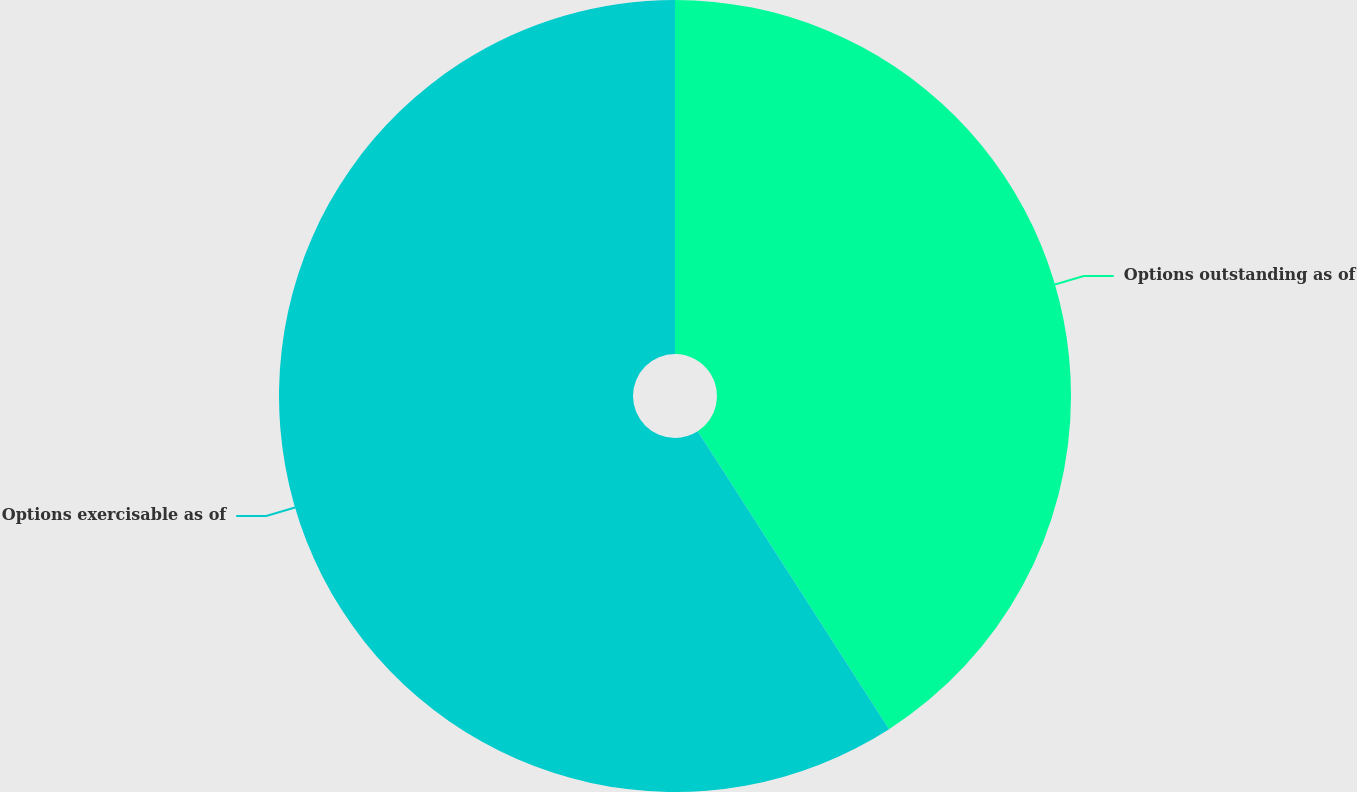Convert chart to OTSL. <chart><loc_0><loc_0><loc_500><loc_500><pie_chart><fcel>Options outstanding as of<fcel>Options exercisable as of<nl><fcel>40.91%<fcel>59.09%<nl></chart> 